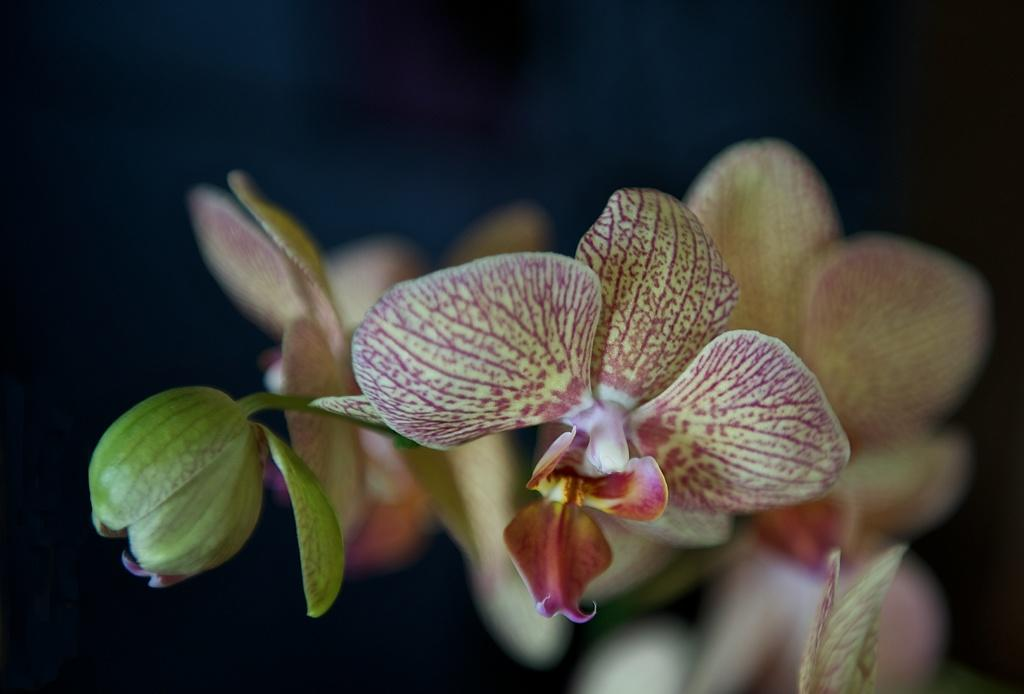What type of plants are in the image? The image contains flowers. What colors are the flowers in the image? The flowers are in yellow and pink colors. What type of cherry is present in the image? There is no cherry present in the image; it features flowers in yellow and pink colors. What disease can be seen affecting the flowers in the image? There is no indication of any disease affecting the flowers in the image. 